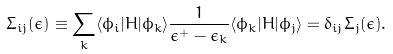Convert formula to latex. <formula><loc_0><loc_0><loc_500><loc_500>\Sigma _ { i j } ( \epsilon ) \equiv \sum _ { k } \langle \phi _ { i } | H | \phi _ { k } \rangle \frac { 1 } { \epsilon ^ { + } - \epsilon _ { k } } \langle \phi _ { k } | H | \phi _ { j } \rangle = \delta _ { i j } \Sigma _ { j } ( \epsilon ) .</formula> 